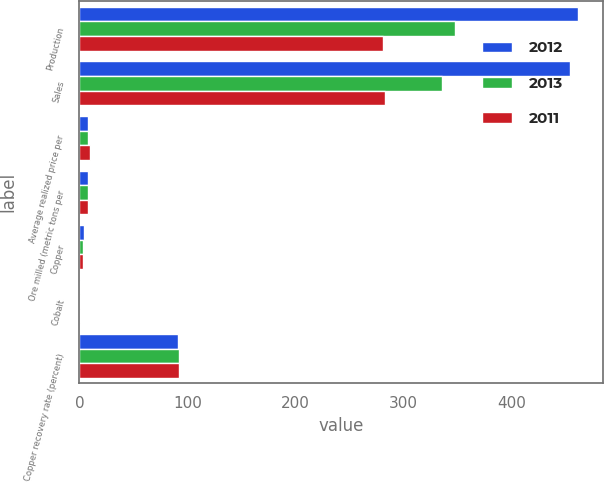<chart> <loc_0><loc_0><loc_500><loc_500><stacked_bar_chart><ecel><fcel>Production<fcel>Sales<fcel>Average realized price per<fcel>Ore milled (metric tons per<fcel>Copper<fcel>Cobalt<fcel>Copper recovery rate (percent)<nl><fcel>2012<fcel>462<fcel>454<fcel>8.02<fcel>8.02<fcel>4.22<fcel>0.37<fcel>91.4<nl><fcel>2013<fcel>348<fcel>336<fcel>7.83<fcel>8.02<fcel>3.62<fcel>0.37<fcel>92.4<nl><fcel>2011<fcel>281<fcel>283<fcel>9.99<fcel>8.02<fcel>3.41<fcel>0.4<fcel>92.5<nl></chart> 